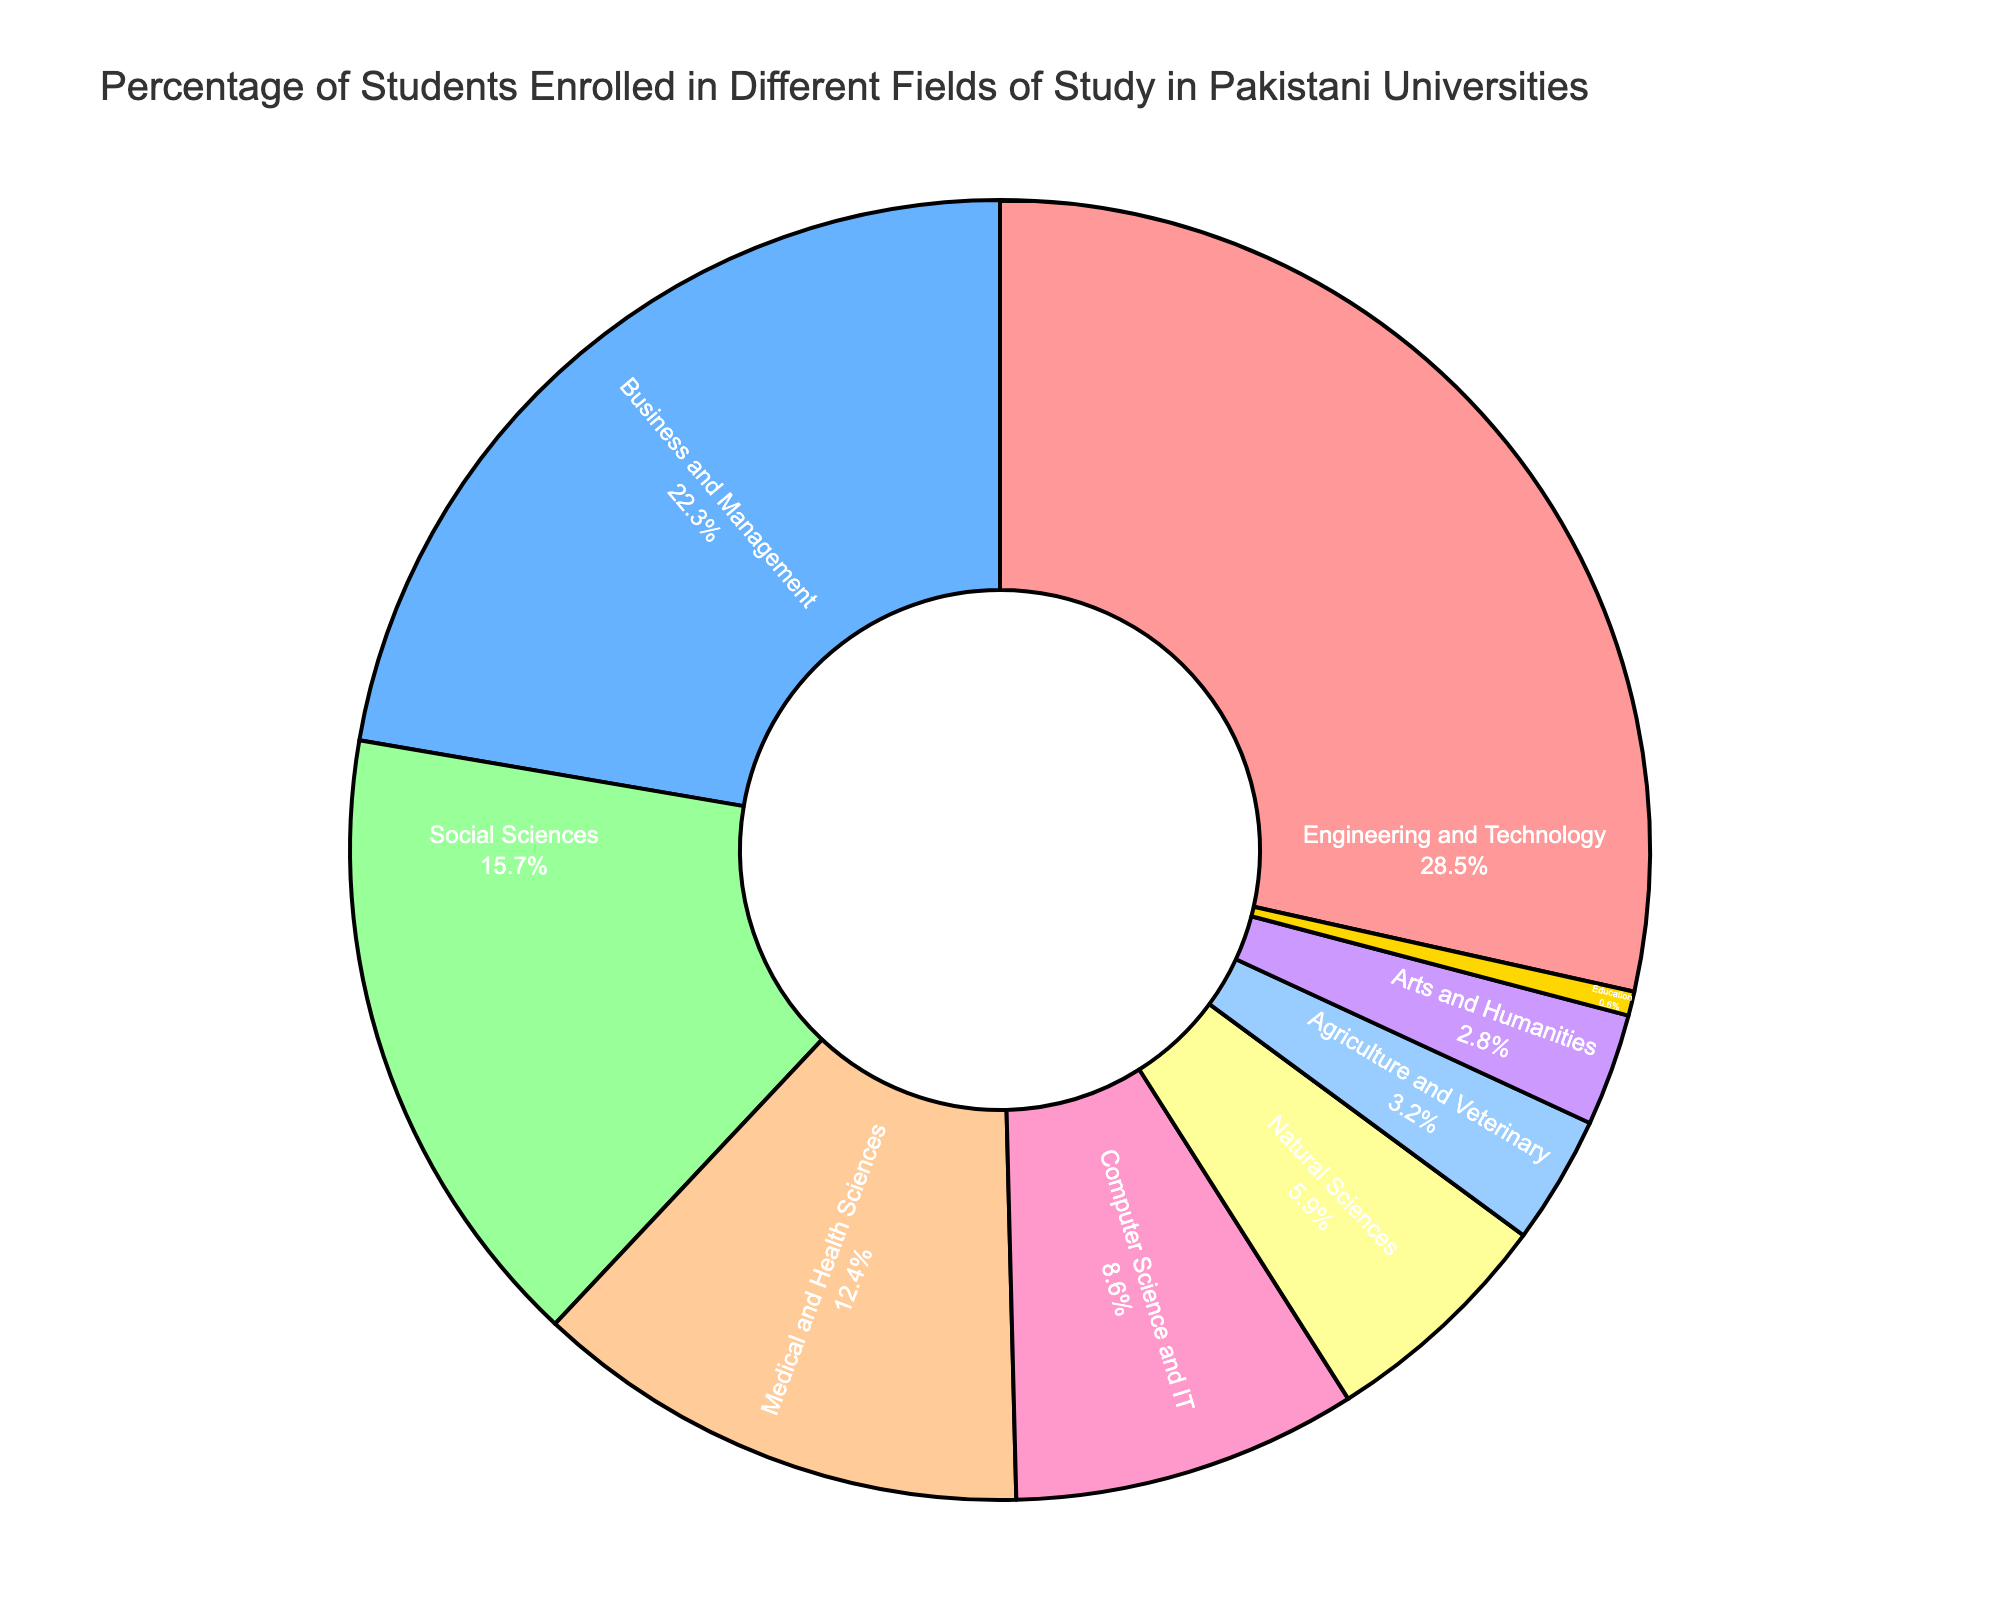What percentage of students are enrolled in Engineering and Technology? The pie chart shows the percentage of students enrolled in different fields of study. For Engineering and Technology, it is marked as 28.5%.
Answer: 28.5% Which field has the lowest percentage of student enrollment? By examining the chart, the smallest segment represents Education, which has the lowest percentage of 0.6%.
Answer: Education How much higher is the percentage of students in Business and Management compared to Computer Science and IT? The chart shows Business and Management at 22.3% and Computer Science and IT at 8.6%. The difference is 22.3% - 8.6% = 13.7%.
Answer: 13.7% What is the total percentage of students enrolled in Medical and Health Sciences, Computer Science and IT, and Natural Sciences combined? According to the chart, Medical and Health Sciences is 12.4%, Computer Science and IT is 8.6%, and Natural Sciences is 5.9%. The total is 12.4% + 8.6% + 5.9% = 26.9%.
Answer: 26.9% Which field of study is represented by the yellow segment in the pie chart? The yellow segment in the chart represents the Arts and Humanities category.
Answer: Arts and Humanities Between Social Sciences and Agriculture and Veterinary, which field has a higher percentage of student enrollment and by how much? Social Sciences have 15.7%, and Agriculture and Veterinary have 3.2%, so Social Sciences have a higher percentage by 15.7% - 3.2% = 12.5%.
Answer: Social Sciences by 12.5% What is the combined percentage of students enrolled in Arts and Humanities and Education? The chart shows 2.8% for Arts and Humanities and 0.6% for Education. The combined percentage is 2.8% + 0.6% = 3.4%.
Answer: 3.4% If the segments were ranked in descending order of student enrollment, which field would be third? From the chart, after Engineering and Technology (28.5%) and Business and Management (22.3%), the next highest is Social Sciences at 15.7%.
Answer: Social Sciences What is the percentage difference between the Engineering and Technology field and the Natural Sciences field? Engineering and Technology is 28.5%, and Natural Sciences is 5.9%. The difference is 28.5% - 5.9% = 22.6%.
Answer: 22.6% How does the percentage of students in Business and Management compare to those in Medical and Health Sciences? Business and Management has 22.3% and Medical and Health Sciences has 12.4%. Thus, Business and Management has a higher percentage by 22.3% - 12.4% = 9.9%.
Answer: Business and Management by 9.9% 